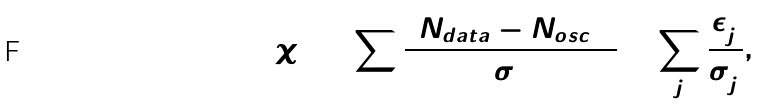<formula> <loc_0><loc_0><loc_500><loc_500>\chi ^ { 2 } = \sum \frac { ( N _ { d a t a } - N _ { o s c } ) ^ { 2 } } { \sigma ^ { 2 } } + \sum _ { j } \frac { \epsilon _ { j } ^ { 2 } } { \sigma _ { j } ^ { 2 } } ,</formula> 